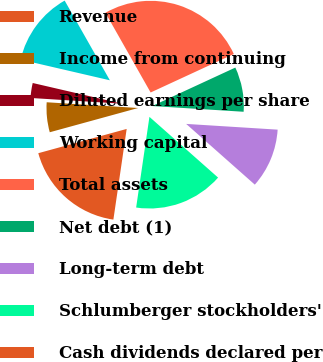<chart> <loc_0><loc_0><loc_500><loc_500><pie_chart><fcel>Revenue<fcel>Income from continuing<fcel>Diluted earnings per share<fcel>Working capital<fcel>Total assets<fcel>Net debt (1)<fcel>Long-term debt<fcel>Schlumberger stockholders'<fcel>Cash dividends declared per<nl><fcel>18.42%<fcel>5.26%<fcel>2.63%<fcel>13.16%<fcel>26.32%<fcel>7.89%<fcel>10.53%<fcel>15.79%<fcel>0.0%<nl></chart> 